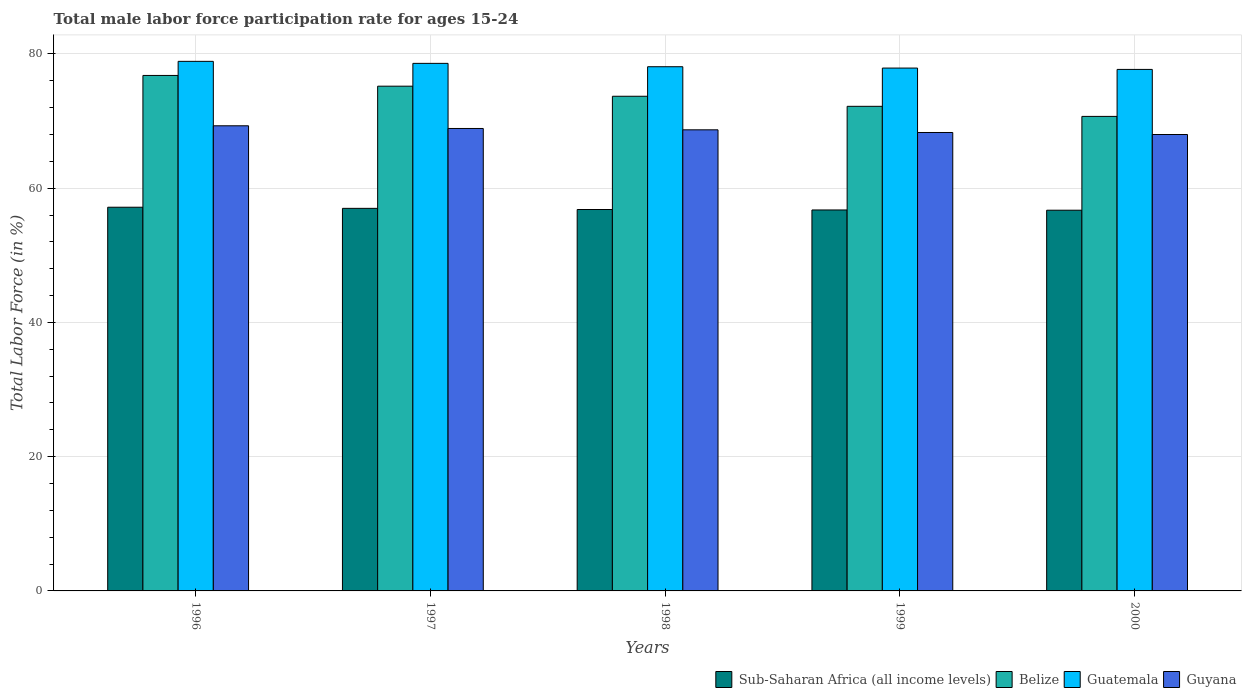How many different coloured bars are there?
Give a very brief answer. 4. How many groups of bars are there?
Your response must be concise. 5. Are the number of bars on each tick of the X-axis equal?
Offer a very short reply. Yes. How many bars are there on the 2nd tick from the left?
Provide a short and direct response. 4. In how many cases, is the number of bars for a given year not equal to the number of legend labels?
Ensure brevity in your answer.  0. What is the male labor force participation rate in Belize in 1996?
Your answer should be very brief. 76.8. Across all years, what is the maximum male labor force participation rate in Belize?
Offer a very short reply. 76.8. Across all years, what is the minimum male labor force participation rate in Belize?
Ensure brevity in your answer.  70.7. In which year was the male labor force participation rate in Guyana maximum?
Offer a terse response. 1996. What is the total male labor force participation rate in Belize in the graph?
Provide a succinct answer. 368.6. What is the difference between the male labor force participation rate in Sub-Saharan Africa (all income levels) in 1996 and that in 1997?
Your response must be concise. 0.17. What is the difference between the male labor force participation rate in Belize in 1997 and the male labor force participation rate in Guatemala in 1999?
Your response must be concise. -2.7. What is the average male labor force participation rate in Guatemala per year?
Your response must be concise. 78.24. In the year 1998, what is the difference between the male labor force participation rate in Belize and male labor force participation rate in Guatemala?
Offer a very short reply. -4.4. What is the ratio of the male labor force participation rate in Sub-Saharan Africa (all income levels) in 1998 to that in 2000?
Offer a terse response. 1. Is the difference between the male labor force participation rate in Belize in 1998 and 2000 greater than the difference between the male labor force participation rate in Guatemala in 1998 and 2000?
Keep it short and to the point. Yes. What is the difference between the highest and the second highest male labor force participation rate in Guatemala?
Your answer should be compact. 0.3. What is the difference between the highest and the lowest male labor force participation rate in Guyana?
Your answer should be compact. 1.3. In how many years, is the male labor force participation rate in Guyana greater than the average male labor force participation rate in Guyana taken over all years?
Ensure brevity in your answer.  3. Is the sum of the male labor force participation rate in Guatemala in 1998 and 2000 greater than the maximum male labor force participation rate in Sub-Saharan Africa (all income levels) across all years?
Offer a terse response. Yes. What does the 4th bar from the left in 1996 represents?
Provide a short and direct response. Guyana. What does the 3rd bar from the right in 1996 represents?
Offer a very short reply. Belize. Is it the case that in every year, the sum of the male labor force participation rate in Guyana and male labor force participation rate in Belize is greater than the male labor force participation rate in Guatemala?
Your answer should be compact. Yes. How many bars are there?
Provide a short and direct response. 20. What is the difference between two consecutive major ticks on the Y-axis?
Make the answer very short. 20. Are the values on the major ticks of Y-axis written in scientific E-notation?
Ensure brevity in your answer.  No. Does the graph contain any zero values?
Your answer should be very brief. No. Where does the legend appear in the graph?
Offer a very short reply. Bottom right. How many legend labels are there?
Provide a succinct answer. 4. What is the title of the graph?
Ensure brevity in your answer.  Total male labor force participation rate for ages 15-24. What is the Total Labor Force (in %) of Sub-Saharan Africa (all income levels) in 1996?
Provide a succinct answer. 57.17. What is the Total Labor Force (in %) in Belize in 1996?
Keep it short and to the point. 76.8. What is the Total Labor Force (in %) in Guatemala in 1996?
Your answer should be compact. 78.9. What is the Total Labor Force (in %) in Guyana in 1996?
Provide a succinct answer. 69.3. What is the Total Labor Force (in %) in Sub-Saharan Africa (all income levels) in 1997?
Provide a succinct answer. 57. What is the Total Labor Force (in %) of Belize in 1997?
Your response must be concise. 75.2. What is the Total Labor Force (in %) in Guatemala in 1997?
Ensure brevity in your answer.  78.6. What is the Total Labor Force (in %) of Guyana in 1997?
Give a very brief answer. 68.9. What is the Total Labor Force (in %) of Sub-Saharan Africa (all income levels) in 1998?
Your response must be concise. 56.83. What is the Total Labor Force (in %) in Belize in 1998?
Give a very brief answer. 73.7. What is the Total Labor Force (in %) of Guatemala in 1998?
Provide a succinct answer. 78.1. What is the Total Labor Force (in %) in Guyana in 1998?
Ensure brevity in your answer.  68.7. What is the Total Labor Force (in %) in Sub-Saharan Africa (all income levels) in 1999?
Offer a terse response. 56.76. What is the Total Labor Force (in %) in Belize in 1999?
Provide a short and direct response. 72.2. What is the Total Labor Force (in %) of Guatemala in 1999?
Make the answer very short. 77.9. What is the Total Labor Force (in %) in Guyana in 1999?
Offer a terse response. 68.3. What is the Total Labor Force (in %) of Sub-Saharan Africa (all income levels) in 2000?
Offer a very short reply. 56.72. What is the Total Labor Force (in %) of Belize in 2000?
Your answer should be very brief. 70.7. What is the Total Labor Force (in %) in Guatemala in 2000?
Make the answer very short. 77.7. Across all years, what is the maximum Total Labor Force (in %) in Sub-Saharan Africa (all income levels)?
Provide a succinct answer. 57.17. Across all years, what is the maximum Total Labor Force (in %) of Belize?
Your response must be concise. 76.8. Across all years, what is the maximum Total Labor Force (in %) of Guatemala?
Offer a very short reply. 78.9. Across all years, what is the maximum Total Labor Force (in %) of Guyana?
Offer a terse response. 69.3. Across all years, what is the minimum Total Labor Force (in %) of Sub-Saharan Africa (all income levels)?
Your response must be concise. 56.72. Across all years, what is the minimum Total Labor Force (in %) of Belize?
Provide a short and direct response. 70.7. Across all years, what is the minimum Total Labor Force (in %) in Guatemala?
Ensure brevity in your answer.  77.7. Across all years, what is the minimum Total Labor Force (in %) in Guyana?
Give a very brief answer. 68. What is the total Total Labor Force (in %) of Sub-Saharan Africa (all income levels) in the graph?
Keep it short and to the point. 284.47. What is the total Total Labor Force (in %) of Belize in the graph?
Your answer should be compact. 368.6. What is the total Total Labor Force (in %) of Guatemala in the graph?
Provide a succinct answer. 391.2. What is the total Total Labor Force (in %) of Guyana in the graph?
Provide a short and direct response. 343.2. What is the difference between the Total Labor Force (in %) of Sub-Saharan Africa (all income levels) in 1996 and that in 1997?
Give a very brief answer. 0.17. What is the difference between the Total Labor Force (in %) in Belize in 1996 and that in 1997?
Keep it short and to the point. 1.6. What is the difference between the Total Labor Force (in %) in Guyana in 1996 and that in 1997?
Your answer should be compact. 0.4. What is the difference between the Total Labor Force (in %) in Sub-Saharan Africa (all income levels) in 1996 and that in 1998?
Offer a very short reply. 0.34. What is the difference between the Total Labor Force (in %) of Guatemala in 1996 and that in 1998?
Offer a terse response. 0.8. What is the difference between the Total Labor Force (in %) in Sub-Saharan Africa (all income levels) in 1996 and that in 1999?
Your response must be concise. 0.41. What is the difference between the Total Labor Force (in %) of Sub-Saharan Africa (all income levels) in 1996 and that in 2000?
Make the answer very short. 0.44. What is the difference between the Total Labor Force (in %) in Belize in 1996 and that in 2000?
Offer a very short reply. 6.1. What is the difference between the Total Labor Force (in %) of Guatemala in 1996 and that in 2000?
Ensure brevity in your answer.  1.2. What is the difference between the Total Labor Force (in %) of Sub-Saharan Africa (all income levels) in 1997 and that in 1998?
Keep it short and to the point. 0.17. What is the difference between the Total Labor Force (in %) in Sub-Saharan Africa (all income levels) in 1997 and that in 1999?
Provide a short and direct response. 0.24. What is the difference between the Total Labor Force (in %) in Guatemala in 1997 and that in 1999?
Provide a succinct answer. 0.7. What is the difference between the Total Labor Force (in %) in Guyana in 1997 and that in 1999?
Make the answer very short. 0.6. What is the difference between the Total Labor Force (in %) of Sub-Saharan Africa (all income levels) in 1997 and that in 2000?
Provide a short and direct response. 0.28. What is the difference between the Total Labor Force (in %) of Guatemala in 1997 and that in 2000?
Offer a terse response. 0.9. What is the difference between the Total Labor Force (in %) in Sub-Saharan Africa (all income levels) in 1998 and that in 1999?
Ensure brevity in your answer.  0.07. What is the difference between the Total Labor Force (in %) in Guatemala in 1998 and that in 1999?
Your answer should be very brief. 0.2. What is the difference between the Total Labor Force (in %) in Guyana in 1998 and that in 1999?
Your answer should be compact. 0.4. What is the difference between the Total Labor Force (in %) in Sub-Saharan Africa (all income levels) in 1998 and that in 2000?
Your answer should be compact. 0.1. What is the difference between the Total Labor Force (in %) in Belize in 1998 and that in 2000?
Offer a very short reply. 3. What is the difference between the Total Labor Force (in %) of Guatemala in 1998 and that in 2000?
Offer a very short reply. 0.4. What is the difference between the Total Labor Force (in %) of Guyana in 1998 and that in 2000?
Provide a short and direct response. 0.7. What is the difference between the Total Labor Force (in %) of Sub-Saharan Africa (all income levels) in 1999 and that in 2000?
Your answer should be very brief. 0.04. What is the difference between the Total Labor Force (in %) in Sub-Saharan Africa (all income levels) in 1996 and the Total Labor Force (in %) in Belize in 1997?
Your answer should be very brief. -18.03. What is the difference between the Total Labor Force (in %) of Sub-Saharan Africa (all income levels) in 1996 and the Total Labor Force (in %) of Guatemala in 1997?
Your answer should be very brief. -21.43. What is the difference between the Total Labor Force (in %) in Sub-Saharan Africa (all income levels) in 1996 and the Total Labor Force (in %) in Guyana in 1997?
Provide a succinct answer. -11.73. What is the difference between the Total Labor Force (in %) in Belize in 1996 and the Total Labor Force (in %) in Guatemala in 1997?
Provide a short and direct response. -1.8. What is the difference between the Total Labor Force (in %) in Belize in 1996 and the Total Labor Force (in %) in Guyana in 1997?
Provide a succinct answer. 7.9. What is the difference between the Total Labor Force (in %) of Guatemala in 1996 and the Total Labor Force (in %) of Guyana in 1997?
Offer a terse response. 10. What is the difference between the Total Labor Force (in %) of Sub-Saharan Africa (all income levels) in 1996 and the Total Labor Force (in %) of Belize in 1998?
Your response must be concise. -16.53. What is the difference between the Total Labor Force (in %) of Sub-Saharan Africa (all income levels) in 1996 and the Total Labor Force (in %) of Guatemala in 1998?
Provide a succinct answer. -20.93. What is the difference between the Total Labor Force (in %) in Sub-Saharan Africa (all income levels) in 1996 and the Total Labor Force (in %) in Guyana in 1998?
Make the answer very short. -11.53. What is the difference between the Total Labor Force (in %) of Belize in 1996 and the Total Labor Force (in %) of Guyana in 1998?
Offer a terse response. 8.1. What is the difference between the Total Labor Force (in %) of Sub-Saharan Africa (all income levels) in 1996 and the Total Labor Force (in %) of Belize in 1999?
Offer a terse response. -15.03. What is the difference between the Total Labor Force (in %) of Sub-Saharan Africa (all income levels) in 1996 and the Total Labor Force (in %) of Guatemala in 1999?
Your answer should be very brief. -20.73. What is the difference between the Total Labor Force (in %) of Sub-Saharan Africa (all income levels) in 1996 and the Total Labor Force (in %) of Guyana in 1999?
Ensure brevity in your answer.  -11.13. What is the difference between the Total Labor Force (in %) in Sub-Saharan Africa (all income levels) in 1996 and the Total Labor Force (in %) in Belize in 2000?
Your answer should be compact. -13.53. What is the difference between the Total Labor Force (in %) of Sub-Saharan Africa (all income levels) in 1996 and the Total Labor Force (in %) of Guatemala in 2000?
Offer a terse response. -20.53. What is the difference between the Total Labor Force (in %) of Sub-Saharan Africa (all income levels) in 1996 and the Total Labor Force (in %) of Guyana in 2000?
Make the answer very short. -10.83. What is the difference between the Total Labor Force (in %) in Belize in 1996 and the Total Labor Force (in %) in Guyana in 2000?
Offer a very short reply. 8.8. What is the difference between the Total Labor Force (in %) in Sub-Saharan Africa (all income levels) in 1997 and the Total Labor Force (in %) in Belize in 1998?
Your answer should be very brief. -16.7. What is the difference between the Total Labor Force (in %) in Sub-Saharan Africa (all income levels) in 1997 and the Total Labor Force (in %) in Guatemala in 1998?
Your answer should be compact. -21.1. What is the difference between the Total Labor Force (in %) in Sub-Saharan Africa (all income levels) in 1997 and the Total Labor Force (in %) in Guyana in 1998?
Keep it short and to the point. -11.7. What is the difference between the Total Labor Force (in %) in Belize in 1997 and the Total Labor Force (in %) in Guatemala in 1998?
Your answer should be compact. -2.9. What is the difference between the Total Labor Force (in %) of Guatemala in 1997 and the Total Labor Force (in %) of Guyana in 1998?
Offer a very short reply. 9.9. What is the difference between the Total Labor Force (in %) in Sub-Saharan Africa (all income levels) in 1997 and the Total Labor Force (in %) in Belize in 1999?
Ensure brevity in your answer.  -15.2. What is the difference between the Total Labor Force (in %) of Sub-Saharan Africa (all income levels) in 1997 and the Total Labor Force (in %) of Guatemala in 1999?
Provide a succinct answer. -20.9. What is the difference between the Total Labor Force (in %) in Sub-Saharan Africa (all income levels) in 1997 and the Total Labor Force (in %) in Guyana in 1999?
Make the answer very short. -11.3. What is the difference between the Total Labor Force (in %) in Belize in 1997 and the Total Labor Force (in %) in Guyana in 1999?
Make the answer very short. 6.9. What is the difference between the Total Labor Force (in %) in Guatemala in 1997 and the Total Labor Force (in %) in Guyana in 1999?
Your answer should be compact. 10.3. What is the difference between the Total Labor Force (in %) of Sub-Saharan Africa (all income levels) in 1997 and the Total Labor Force (in %) of Belize in 2000?
Your answer should be very brief. -13.7. What is the difference between the Total Labor Force (in %) of Sub-Saharan Africa (all income levels) in 1997 and the Total Labor Force (in %) of Guatemala in 2000?
Offer a very short reply. -20.7. What is the difference between the Total Labor Force (in %) in Sub-Saharan Africa (all income levels) in 1997 and the Total Labor Force (in %) in Guyana in 2000?
Keep it short and to the point. -11. What is the difference between the Total Labor Force (in %) in Sub-Saharan Africa (all income levels) in 1998 and the Total Labor Force (in %) in Belize in 1999?
Your response must be concise. -15.37. What is the difference between the Total Labor Force (in %) in Sub-Saharan Africa (all income levels) in 1998 and the Total Labor Force (in %) in Guatemala in 1999?
Make the answer very short. -21.07. What is the difference between the Total Labor Force (in %) in Sub-Saharan Africa (all income levels) in 1998 and the Total Labor Force (in %) in Guyana in 1999?
Offer a very short reply. -11.47. What is the difference between the Total Labor Force (in %) of Belize in 1998 and the Total Labor Force (in %) of Guyana in 1999?
Offer a very short reply. 5.4. What is the difference between the Total Labor Force (in %) of Guatemala in 1998 and the Total Labor Force (in %) of Guyana in 1999?
Provide a short and direct response. 9.8. What is the difference between the Total Labor Force (in %) in Sub-Saharan Africa (all income levels) in 1998 and the Total Labor Force (in %) in Belize in 2000?
Make the answer very short. -13.87. What is the difference between the Total Labor Force (in %) in Sub-Saharan Africa (all income levels) in 1998 and the Total Labor Force (in %) in Guatemala in 2000?
Your response must be concise. -20.87. What is the difference between the Total Labor Force (in %) in Sub-Saharan Africa (all income levels) in 1998 and the Total Labor Force (in %) in Guyana in 2000?
Ensure brevity in your answer.  -11.17. What is the difference between the Total Labor Force (in %) of Belize in 1998 and the Total Labor Force (in %) of Guatemala in 2000?
Make the answer very short. -4. What is the difference between the Total Labor Force (in %) in Sub-Saharan Africa (all income levels) in 1999 and the Total Labor Force (in %) in Belize in 2000?
Keep it short and to the point. -13.94. What is the difference between the Total Labor Force (in %) of Sub-Saharan Africa (all income levels) in 1999 and the Total Labor Force (in %) of Guatemala in 2000?
Ensure brevity in your answer.  -20.94. What is the difference between the Total Labor Force (in %) of Sub-Saharan Africa (all income levels) in 1999 and the Total Labor Force (in %) of Guyana in 2000?
Give a very brief answer. -11.24. What is the difference between the Total Labor Force (in %) in Belize in 1999 and the Total Labor Force (in %) in Guatemala in 2000?
Offer a terse response. -5.5. What is the difference between the Total Labor Force (in %) in Belize in 1999 and the Total Labor Force (in %) in Guyana in 2000?
Offer a terse response. 4.2. What is the difference between the Total Labor Force (in %) in Guatemala in 1999 and the Total Labor Force (in %) in Guyana in 2000?
Your answer should be very brief. 9.9. What is the average Total Labor Force (in %) in Sub-Saharan Africa (all income levels) per year?
Provide a short and direct response. 56.89. What is the average Total Labor Force (in %) in Belize per year?
Make the answer very short. 73.72. What is the average Total Labor Force (in %) in Guatemala per year?
Give a very brief answer. 78.24. What is the average Total Labor Force (in %) in Guyana per year?
Your answer should be compact. 68.64. In the year 1996, what is the difference between the Total Labor Force (in %) in Sub-Saharan Africa (all income levels) and Total Labor Force (in %) in Belize?
Make the answer very short. -19.63. In the year 1996, what is the difference between the Total Labor Force (in %) in Sub-Saharan Africa (all income levels) and Total Labor Force (in %) in Guatemala?
Provide a succinct answer. -21.73. In the year 1996, what is the difference between the Total Labor Force (in %) of Sub-Saharan Africa (all income levels) and Total Labor Force (in %) of Guyana?
Your answer should be compact. -12.13. In the year 1996, what is the difference between the Total Labor Force (in %) in Belize and Total Labor Force (in %) in Guatemala?
Your answer should be very brief. -2.1. In the year 1996, what is the difference between the Total Labor Force (in %) in Belize and Total Labor Force (in %) in Guyana?
Ensure brevity in your answer.  7.5. In the year 1996, what is the difference between the Total Labor Force (in %) in Guatemala and Total Labor Force (in %) in Guyana?
Ensure brevity in your answer.  9.6. In the year 1997, what is the difference between the Total Labor Force (in %) in Sub-Saharan Africa (all income levels) and Total Labor Force (in %) in Belize?
Make the answer very short. -18.2. In the year 1997, what is the difference between the Total Labor Force (in %) in Sub-Saharan Africa (all income levels) and Total Labor Force (in %) in Guatemala?
Offer a very short reply. -21.6. In the year 1997, what is the difference between the Total Labor Force (in %) in Sub-Saharan Africa (all income levels) and Total Labor Force (in %) in Guyana?
Offer a very short reply. -11.9. In the year 1997, what is the difference between the Total Labor Force (in %) in Belize and Total Labor Force (in %) in Guyana?
Ensure brevity in your answer.  6.3. In the year 1998, what is the difference between the Total Labor Force (in %) in Sub-Saharan Africa (all income levels) and Total Labor Force (in %) in Belize?
Your answer should be very brief. -16.87. In the year 1998, what is the difference between the Total Labor Force (in %) of Sub-Saharan Africa (all income levels) and Total Labor Force (in %) of Guatemala?
Provide a short and direct response. -21.27. In the year 1998, what is the difference between the Total Labor Force (in %) in Sub-Saharan Africa (all income levels) and Total Labor Force (in %) in Guyana?
Your answer should be very brief. -11.87. In the year 1998, what is the difference between the Total Labor Force (in %) in Belize and Total Labor Force (in %) in Guatemala?
Your response must be concise. -4.4. In the year 1998, what is the difference between the Total Labor Force (in %) of Guatemala and Total Labor Force (in %) of Guyana?
Ensure brevity in your answer.  9.4. In the year 1999, what is the difference between the Total Labor Force (in %) of Sub-Saharan Africa (all income levels) and Total Labor Force (in %) of Belize?
Provide a succinct answer. -15.44. In the year 1999, what is the difference between the Total Labor Force (in %) of Sub-Saharan Africa (all income levels) and Total Labor Force (in %) of Guatemala?
Make the answer very short. -21.14. In the year 1999, what is the difference between the Total Labor Force (in %) of Sub-Saharan Africa (all income levels) and Total Labor Force (in %) of Guyana?
Your answer should be very brief. -11.54. In the year 1999, what is the difference between the Total Labor Force (in %) in Belize and Total Labor Force (in %) in Guyana?
Ensure brevity in your answer.  3.9. In the year 2000, what is the difference between the Total Labor Force (in %) of Sub-Saharan Africa (all income levels) and Total Labor Force (in %) of Belize?
Keep it short and to the point. -13.98. In the year 2000, what is the difference between the Total Labor Force (in %) in Sub-Saharan Africa (all income levels) and Total Labor Force (in %) in Guatemala?
Ensure brevity in your answer.  -20.98. In the year 2000, what is the difference between the Total Labor Force (in %) in Sub-Saharan Africa (all income levels) and Total Labor Force (in %) in Guyana?
Your answer should be very brief. -11.28. In the year 2000, what is the difference between the Total Labor Force (in %) of Belize and Total Labor Force (in %) of Guyana?
Offer a very short reply. 2.7. What is the ratio of the Total Labor Force (in %) of Sub-Saharan Africa (all income levels) in 1996 to that in 1997?
Give a very brief answer. 1. What is the ratio of the Total Labor Force (in %) in Belize in 1996 to that in 1997?
Make the answer very short. 1.02. What is the ratio of the Total Labor Force (in %) of Guatemala in 1996 to that in 1997?
Make the answer very short. 1. What is the ratio of the Total Labor Force (in %) in Guyana in 1996 to that in 1997?
Offer a very short reply. 1.01. What is the ratio of the Total Labor Force (in %) of Belize in 1996 to that in 1998?
Your response must be concise. 1.04. What is the ratio of the Total Labor Force (in %) of Guatemala in 1996 to that in 1998?
Ensure brevity in your answer.  1.01. What is the ratio of the Total Labor Force (in %) of Guyana in 1996 to that in 1998?
Your answer should be very brief. 1.01. What is the ratio of the Total Labor Force (in %) in Sub-Saharan Africa (all income levels) in 1996 to that in 1999?
Provide a short and direct response. 1.01. What is the ratio of the Total Labor Force (in %) in Belize in 1996 to that in 1999?
Offer a terse response. 1.06. What is the ratio of the Total Labor Force (in %) of Guatemala in 1996 to that in 1999?
Offer a very short reply. 1.01. What is the ratio of the Total Labor Force (in %) of Guyana in 1996 to that in 1999?
Provide a succinct answer. 1.01. What is the ratio of the Total Labor Force (in %) of Sub-Saharan Africa (all income levels) in 1996 to that in 2000?
Make the answer very short. 1.01. What is the ratio of the Total Labor Force (in %) of Belize in 1996 to that in 2000?
Provide a succinct answer. 1.09. What is the ratio of the Total Labor Force (in %) in Guatemala in 1996 to that in 2000?
Provide a succinct answer. 1.02. What is the ratio of the Total Labor Force (in %) in Guyana in 1996 to that in 2000?
Your answer should be very brief. 1.02. What is the ratio of the Total Labor Force (in %) in Belize in 1997 to that in 1998?
Provide a succinct answer. 1.02. What is the ratio of the Total Labor Force (in %) in Guatemala in 1997 to that in 1998?
Your answer should be very brief. 1.01. What is the ratio of the Total Labor Force (in %) of Sub-Saharan Africa (all income levels) in 1997 to that in 1999?
Your answer should be compact. 1. What is the ratio of the Total Labor Force (in %) of Belize in 1997 to that in 1999?
Your answer should be compact. 1.04. What is the ratio of the Total Labor Force (in %) in Guatemala in 1997 to that in 1999?
Your answer should be very brief. 1.01. What is the ratio of the Total Labor Force (in %) in Guyana in 1997 to that in 1999?
Your answer should be very brief. 1.01. What is the ratio of the Total Labor Force (in %) of Sub-Saharan Africa (all income levels) in 1997 to that in 2000?
Offer a very short reply. 1. What is the ratio of the Total Labor Force (in %) in Belize in 1997 to that in 2000?
Your response must be concise. 1.06. What is the ratio of the Total Labor Force (in %) in Guatemala in 1997 to that in 2000?
Your response must be concise. 1.01. What is the ratio of the Total Labor Force (in %) in Guyana in 1997 to that in 2000?
Offer a very short reply. 1.01. What is the ratio of the Total Labor Force (in %) in Belize in 1998 to that in 1999?
Provide a succinct answer. 1.02. What is the ratio of the Total Labor Force (in %) in Guatemala in 1998 to that in 1999?
Make the answer very short. 1. What is the ratio of the Total Labor Force (in %) of Guyana in 1998 to that in 1999?
Your answer should be very brief. 1.01. What is the ratio of the Total Labor Force (in %) of Sub-Saharan Africa (all income levels) in 1998 to that in 2000?
Provide a succinct answer. 1. What is the ratio of the Total Labor Force (in %) of Belize in 1998 to that in 2000?
Your answer should be compact. 1.04. What is the ratio of the Total Labor Force (in %) of Guyana in 1998 to that in 2000?
Keep it short and to the point. 1.01. What is the ratio of the Total Labor Force (in %) of Belize in 1999 to that in 2000?
Your answer should be very brief. 1.02. What is the ratio of the Total Labor Force (in %) of Guatemala in 1999 to that in 2000?
Keep it short and to the point. 1. What is the difference between the highest and the second highest Total Labor Force (in %) of Sub-Saharan Africa (all income levels)?
Provide a succinct answer. 0.17. What is the difference between the highest and the second highest Total Labor Force (in %) in Guatemala?
Your answer should be very brief. 0.3. What is the difference between the highest and the second highest Total Labor Force (in %) in Guyana?
Your answer should be compact. 0.4. What is the difference between the highest and the lowest Total Labor Force (in %) in Sub-Saharan Africa (all income levels)?
Make the answer very short. 0.44. What is the difference between the highest and the lowest Total Labor Force (in %) of Belize?
Make the answer very short. 6.1. 